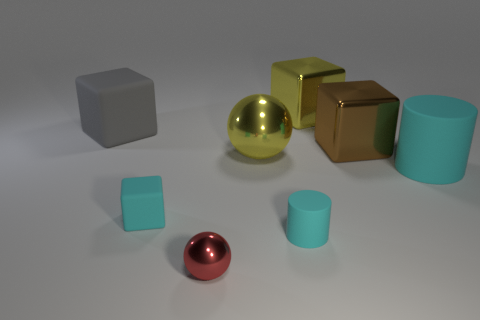What color is the block that is both on the left side of the tiny shiny thing and on the right side of the gray thing?
Make the answer very short. Cyan. What number of cylinders are either big gray matte objects or red things?
Your response must be concise. 0. Is the number of large metal balls behind the brown cube less than the number of rubber cubes?
Keep it short and to the point. Yes. What shape is the big cyan object that is the same material as the gray block?
Offer a very short reply. Cylinder. How many large things are the same color as the small matte cylinder?
Your answer should be very brief. 1. How many objects are either large brown metallic cubes or tiny blocks?
Give a very brief answer. 2. What material is the large thing behind the rubber block that is behind the cyan cube?
Offer a very short reply. Metal. Is there a brown cube made of the same material as the red object?
Offer a terse response. Yes. The large matte thing on the left side of the cyan matte object that is right of the tiny cyan cylinder that is right of the red object is what shape?
Give a very brief answer. Cube. What material is the red sphere?
Keep it short and to the point. Metal. 